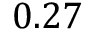Convert formula to latex. <formula><loc_0><loc_0><loc_500><loc_500>0 . 2 7</formula> 